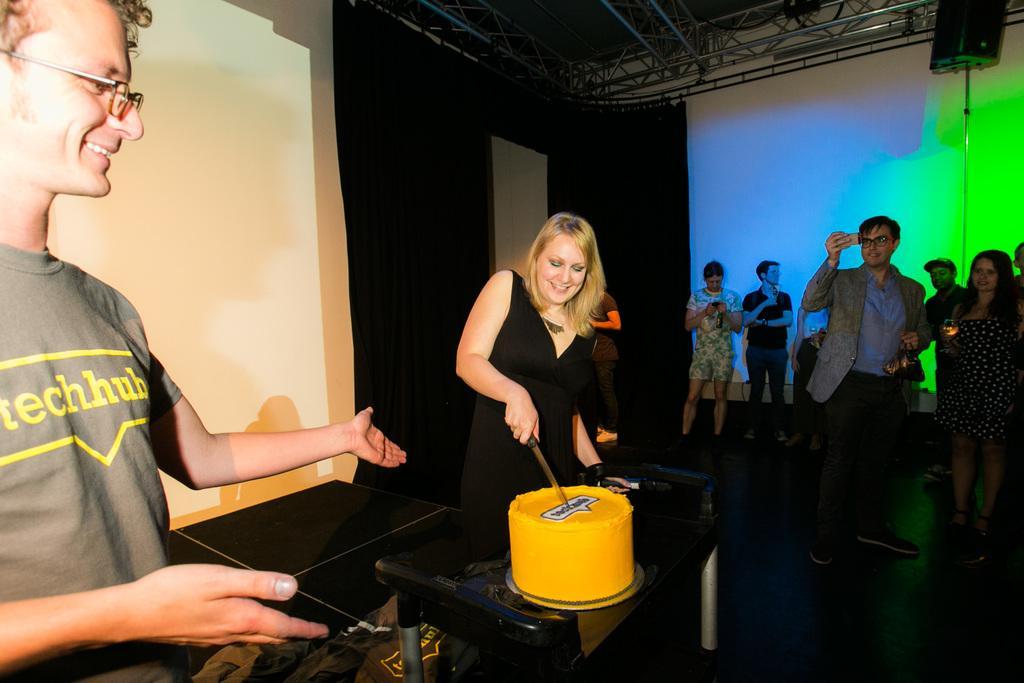Please provide a concise description of this image. In this image in the center of there is one women who is cutting the cake, and in front of her there is a table. And on the left side there is another person standing and smiling, and on the right side there are a group of people some of them are holding mobiles and clicking pictures. And in the background there are lights, curtain, speaker, and at the top there are poles and at the bottom there is floor and objects. 